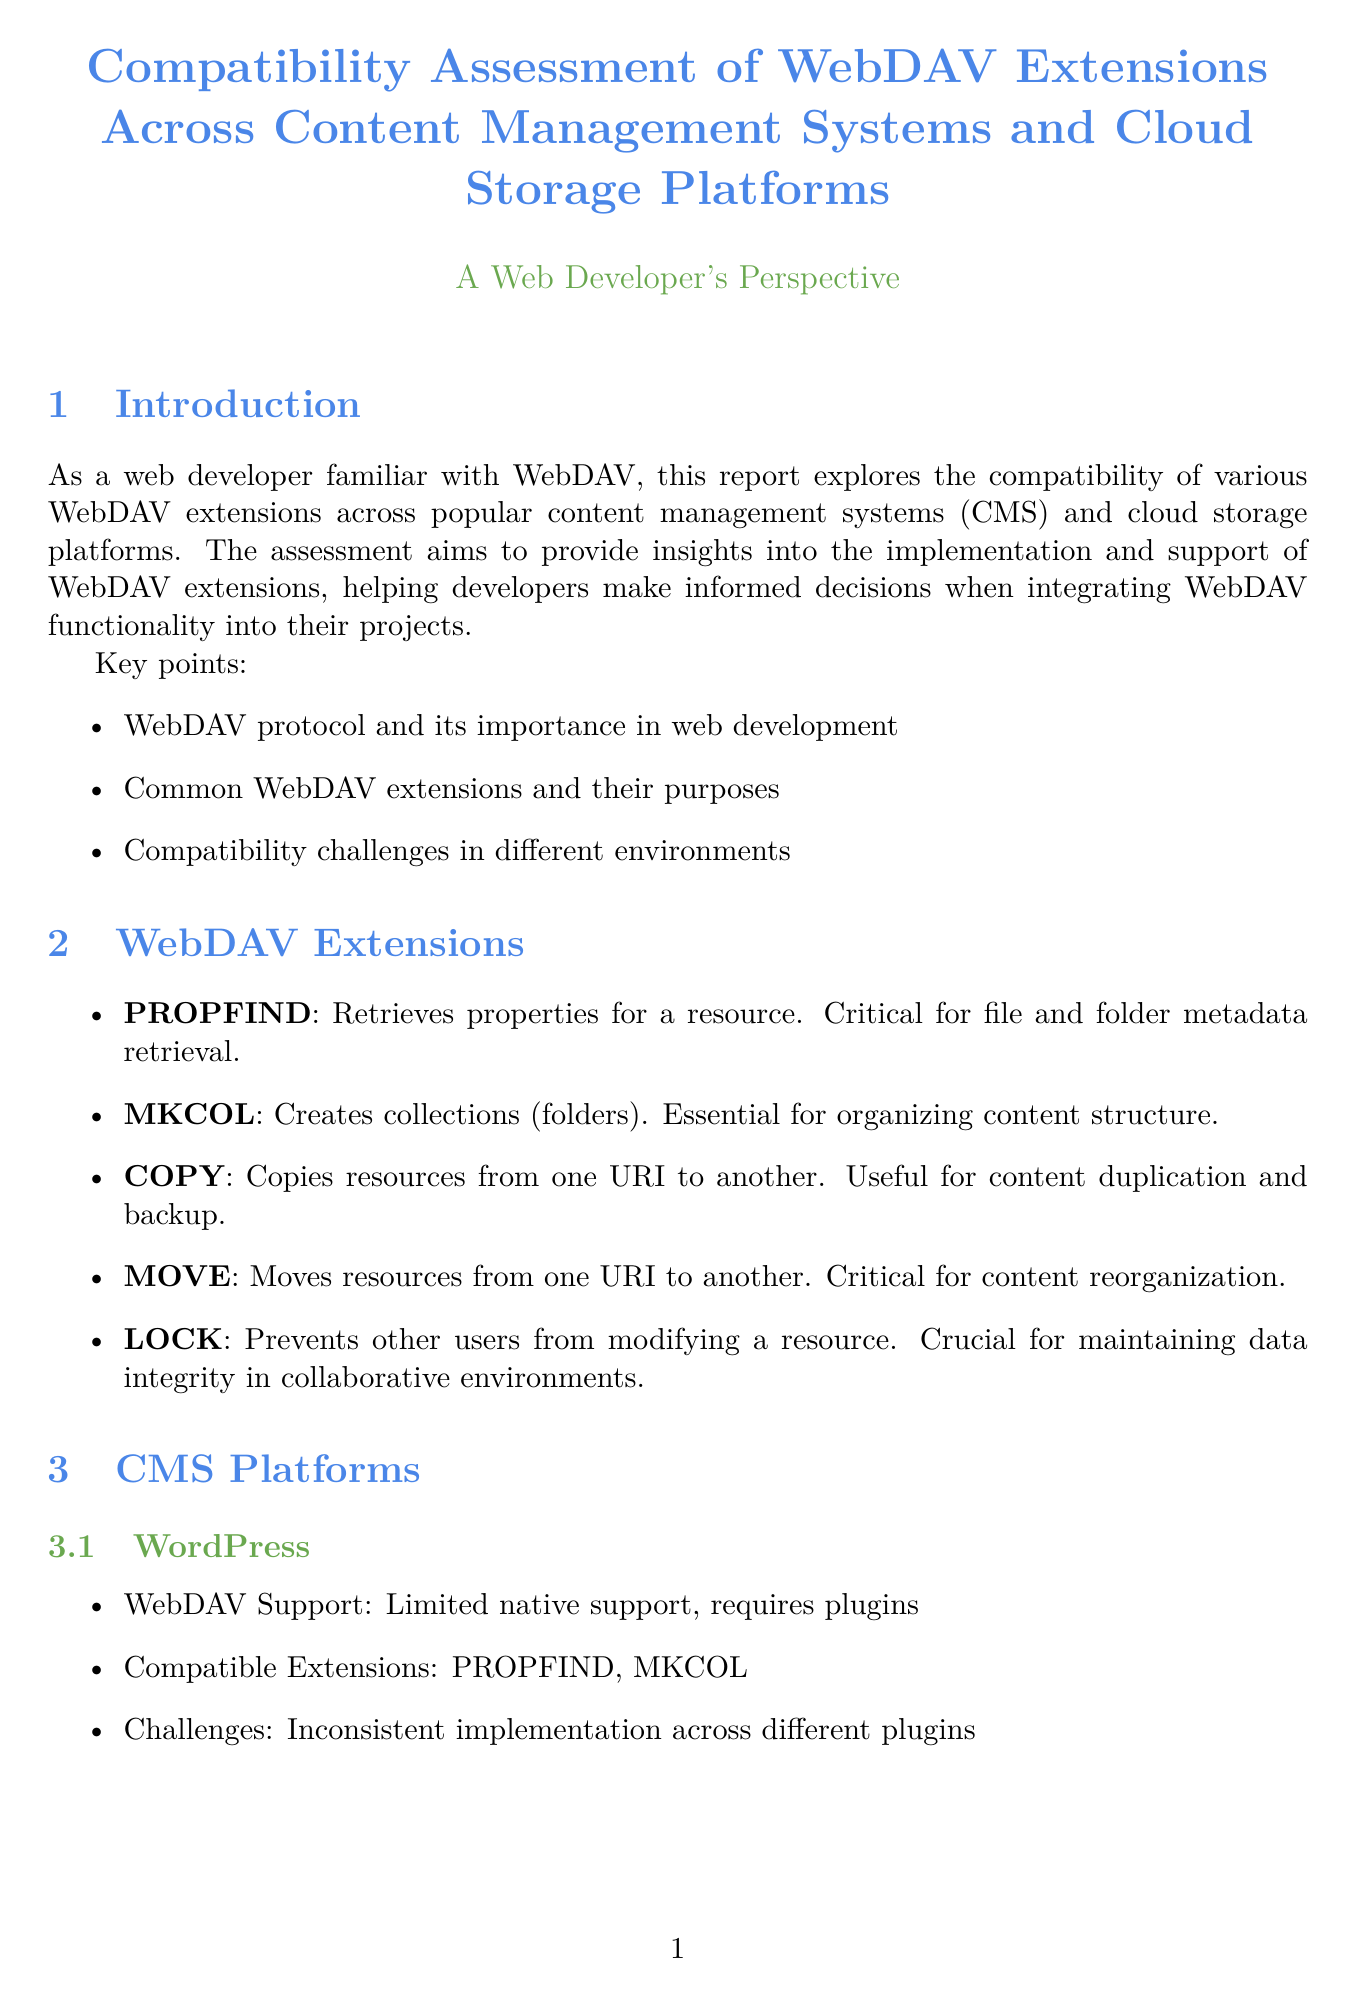What is the title of the report? The title of the report is explicitly stated at the beginning of the document.
Answer: Compatibility Assessment of WebDAV Extensions Across Content Management Systems and Cloud Storage Platforms Which WebDAV extension is critical for file and folder metadata retrieval? The report describes the importance of various WebDAV extensions, and one is specifically mentioned as critical for metadata retrieval.
Answer: PROPFIND What type of support does WordPress have for WebDAV? The report indicates the level of WebDAV support across different platforms, including WordPress.
Answer: Limited native support, requires plugins How many compatible extensions does Joomla support? The document lists the compatible extensions for Joomla, allowing the count of those supported.
Answer: Five Which cloud storage platform offers excellent native WebDAV support? Directly referencing the findings in the report, this cloud storage platform is identified for its support.
Answer: Nextcloud What challenge does Drupal face concerning WebDAV? The report discusses various challenges associated with different platforms, including Drupal's specific challenge.
Answer: Performance issues with large file transfers Which WebDAV extension does Box partially support? The compatibility matrix includes Box's support for each extension, and one was marked as partial.
Answer: LOCK What is one of the implementation considerations mentioned in the report? Various considerations are discussed that are important for implementing WebDAV effectively in projects.
Answer: Security implications of enabling WebDAV on public-facing servers 